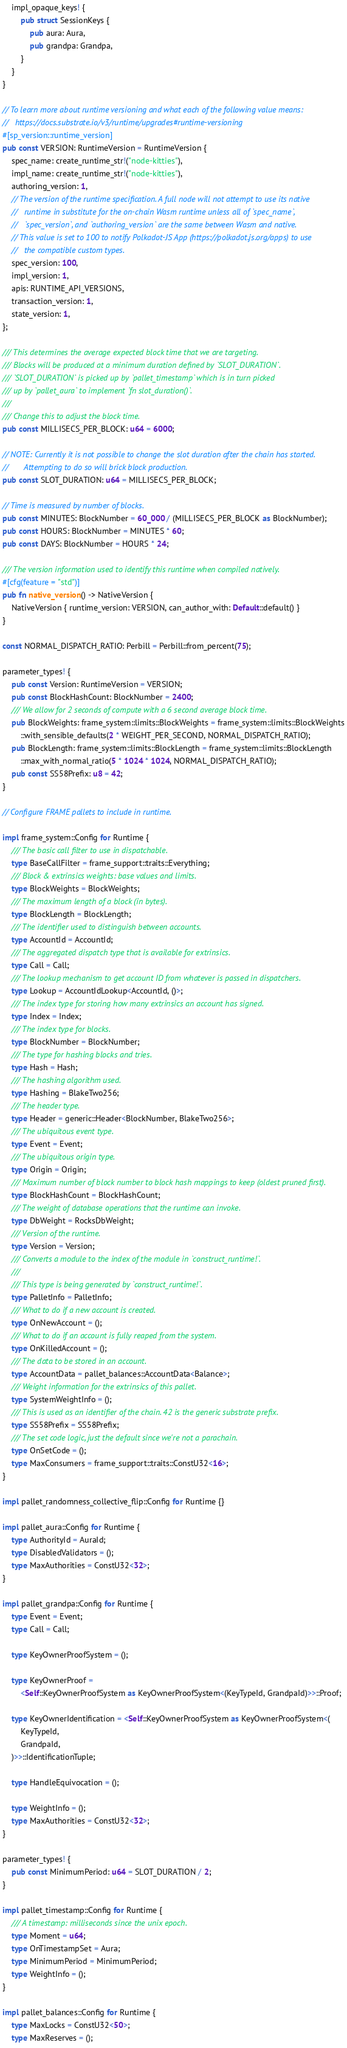Convert code to text. <code><loc_0><loc_0><loc_500><loc_500><_Rust_>	impl_opaque_keys! {
		pub struct SessionKeys {
			pub aura: Aura,
			pub grandpa: Grandpa,
		}
	}
}

// To learn more about runtime versioning and what each of the following value means:
//   https://docs.substrate.io/v3/runtime/upgrades#runtime-versioning
#[sp_version::runtime_version]
pub const VERSION: RuntimeVersion = RuntimeVersion {
	spec_name: create_runtime_str!("node-kitties"),
	impl_name: create_runtime_str!("node-kitties"),
	authoring_version: 1,
	// The version of the runtime specification. A full node will not attempt to use its native
	//   runtime in substitute for the on-chain Wasm runtime unless all of `spec_name`,
	//   `spec_version`, and `authoring_version` are the same between Wasm and native.
	// This value is set to 100 to notify Polkadot-JS App (https://polkadot.js.org/apps) to use
	//   the compatible custom types.
	spec_version: 100,
	impl_version: 1,
	apis: RUNTIME_API_VERSIONS,
	transaction_version: 1,
	state_version: 1,
};

/// This determines the average expected block time that we are targeting.
/// Blocks will be produced at a minimum duration defined by `SLOT_DURATION`.
/// `SLOT_DURATION` is picked up by `pallet_timestamp` which is in turn picked
/// up by `pallet_aura` to implement `fn slot_duration()`.
///
/// Change this to adjust the block time.
pub const MILLISECS_PER_BLOCK: u64 = 6000;

// NOTE: Currently it is not possible to change the slot duration after the chain has started.
//       Attempting to do so will brick block production.
pub const SLOT_DURATION: u64 = MILLISECS_PER_BLOCK;

// Time is measured by number of blocks.
pub const MINUTES: BlockNumber = 60_000 / (MILLISECS_PER_BLOCK as BlockNumber);
pub const HOURS: BlockNumber = MINUTES * 60;
pub const DAYS: BlockNumber = HOURS * 24;

/// The version information used to identify this runtime when compiled natively.
#[cfg(feature = "std")]
pub fn native_version() -> NativeVersion {
	NativeVersion { runtime_version: VERSION, can_author_with: Default::default() }
}

const NORMAL_DISPATCH_RATIO: Perbill = Perbill::from_percent(75);

parameter_types! {
	pub const Version: RuntimeVersion = VERSION;
	pub const BlockHashCount: BlockNumber = 2400;
	/// We allow for 2 seconds of compute with a 6 second average block time.
	pub BlockWeights: frame_system::limits::BlockWeights = frame_system::limits::BlockWeights
		::with_sensible_defaults(2 * WEIGHT_PER_SECOND, NORMAL_DISPATCH_RATIO);
	pub BlockLength: frame_system::limits::BlockLength = frame_system::limits::BlockLength
		::max_with_normal_ratio(5 * 1024 * 1024, NORMAL_DISPATCH_RATIO);
	pub const SS58Prefix: u8 = 42;
}

// Configure FRAME pallets to include in runtime.

impl frame_system::Config for Runtime {
	/// The basic call filter to use in dispatchable.
	type BaseCallFilter = frame_support::traits::Everything;
	/// Block & extrinsics weights: base values and limits.
	type BlockWeights = BlockWeights;
	/// The maximum length of a block (in bytes).
	type BlockLength = BlockLength;
	/// The identifier used to distinguish between accounts.
	type AccountId = AccountId;
	/// The aggregated dispatch type that is available for extrinsics.
	type Call = Call;
	/// The lookup mechanism to get account ID from whatever is passed in dispatchers.
	type Lookup = AccountIdLookup<AccountId, ()>;
	/// The index type for storing how many extrinsics an account has signed.
	type Index = Index;
	/// The index type for blocks.
	type BlockNumber = BlockNumber;
	/// The type for hashing blocks and tries.
	type Hash = Hash;
	/// The hashing algorithm used.
	type Hashing = BlakeTwo256;
	/// The header type.
	type Header = generic::Header<BlockNumber, BlakeTwo256>;
	/// The ubiquitous event type.
	type Event = Event;
	/// The ubiquitous origin type.
	type Origin = Origin;
	/// Maximum number of block number to block hash mappings to keep (oldest pruned first).
	type BlockHashCount = BlockHashCount;
	/// The weight of database operations that the runtime can invoke.
	type DbWeight = RocksDbWeight;
	/// Version of the runtime.
	type Version = Version;
	/// Converts a module to the index of the module in `construct_runtime!`.
	///
	/// This type is being generated by `construct_runtime!`.
	type PalletInfo = PalletInfo;
	/// What to do if a new account is created.
	type OnNewAccount = ();
	/// What to do if an account is fully reaped from the system.
	type OnKilledAccount = ();
	/// The data to be stored in an account.
	type AccountData = pallet_balances::AccountData<Balance>;
	/// Weight information for the extrinsics of this pallet.
	type SystemWeightInfo = ();
	/// This is used as an identifier of the chain. 42 is the generic substrate prefix.
	type SS58Prefix = SS58Prefix;
	/// The set code logic, just the default since we're not a parachain.
	type OnSetCode = ();
	type MaxConsumers = frame_support::traits::ConstU32<16>;
}

impl pallet_randomness_collective_flip::Config for Runtime {}

impl pallet_aura::Config for Runtime {
	type AuthorityId = AuraId;
	type DisabledValidators = ();
	type MaxAuthorities = ConstU32<32>;
}

impl pallet_grandpa::Config for Runtime {
	type Event = Event;
	type Call = Call;

	type KeyOwnerProofSystem = ();

	type KeyOwnerProof =
		<Self::KeyOwnerProofSystem as KeyOwnerProofSystem<(KeyTypeId, GrandpaId)>>::Proof;

	type KeyOwnerIdentification = <Self::KeyOwnerProofSystem as KeyOwnerProofSystem<(
		KeyTypeId,
		GrandpaId,
	)>>::IdentificationTuple;

	type HandleEquivocation = ();

	type WeightInfo = ();
	type MaxAuthorities = ConstU32<32>;
}

parameter_types! {
	pub const MinimumPeriod: u64 = SLOT_DURATION / 2;
}

impl pallet_timestamp::Config for Runtime {
	/// A timestamp: milliseconds since the unix epoch.
	type Moment = u64;
	type OnTimestampSet = Aura;
	type MinimumPeriod = MinimumPeriod;
	type WeightInfo = ();
}

impl pallet_balances::Config for Runtime {
	type MaxLocks = ConstU32<50>;
	type MaxReserves = ();</code> 